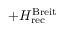Convert formula to latex. <formula><loc_0><loc_0><loc_500><loc_500>+ H _ { r e c } ^ { B r e i t }</formula> 